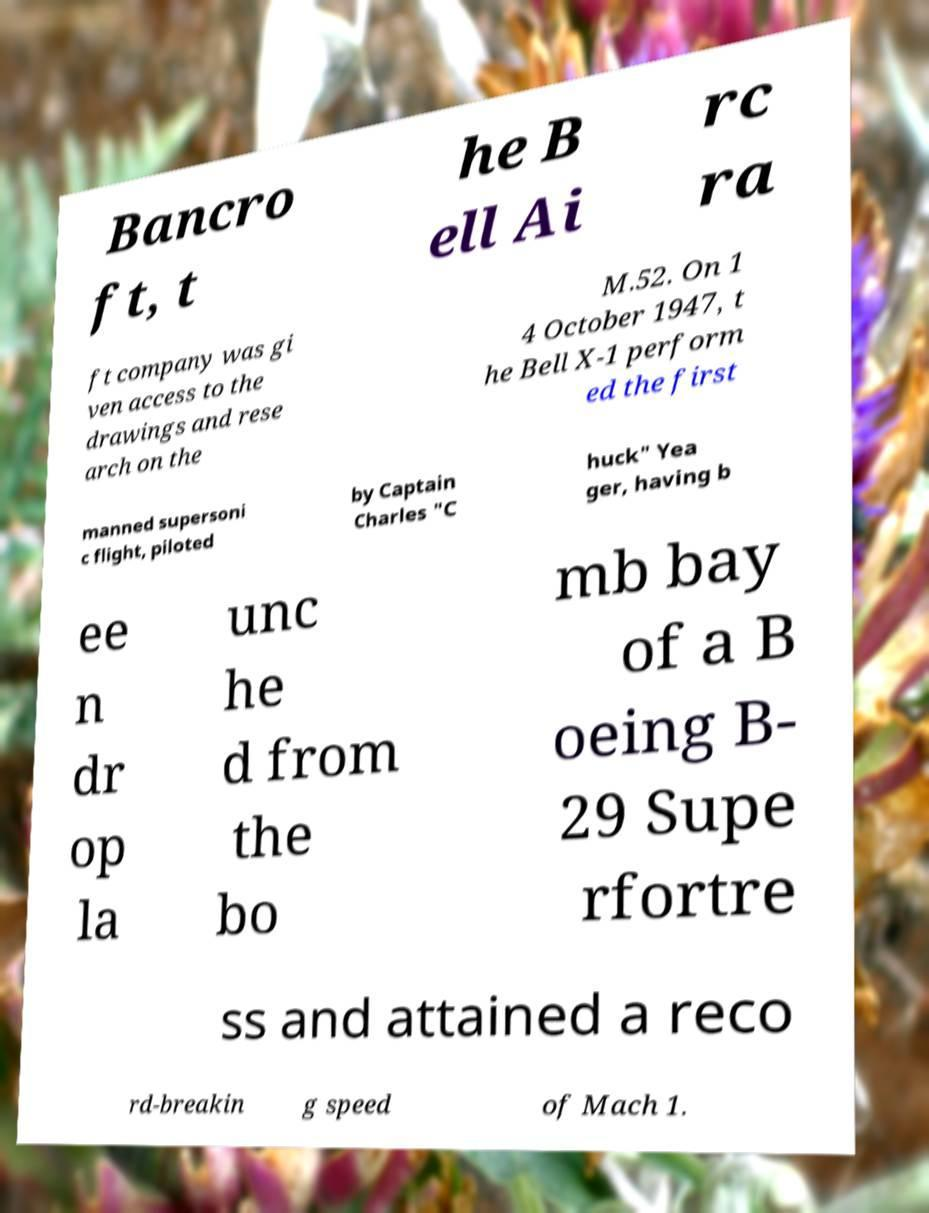Could you extract and type out the text from this image? Bancro ft, t he B ell Ai rc ra ft company was gi ven access to the drawings and rese arch on the M.52. On 1 4 October 1947, t he Bell X-1 perform ed the first manned supersoni c flight, piloted by Captain Charles "C huck" Yea ger, having b ee n dr op la unc he d from the bo mb bay of a B oeing B- 29 Supe rfortre ss and attained a reco rd-breakin g speed of Mach 1. 